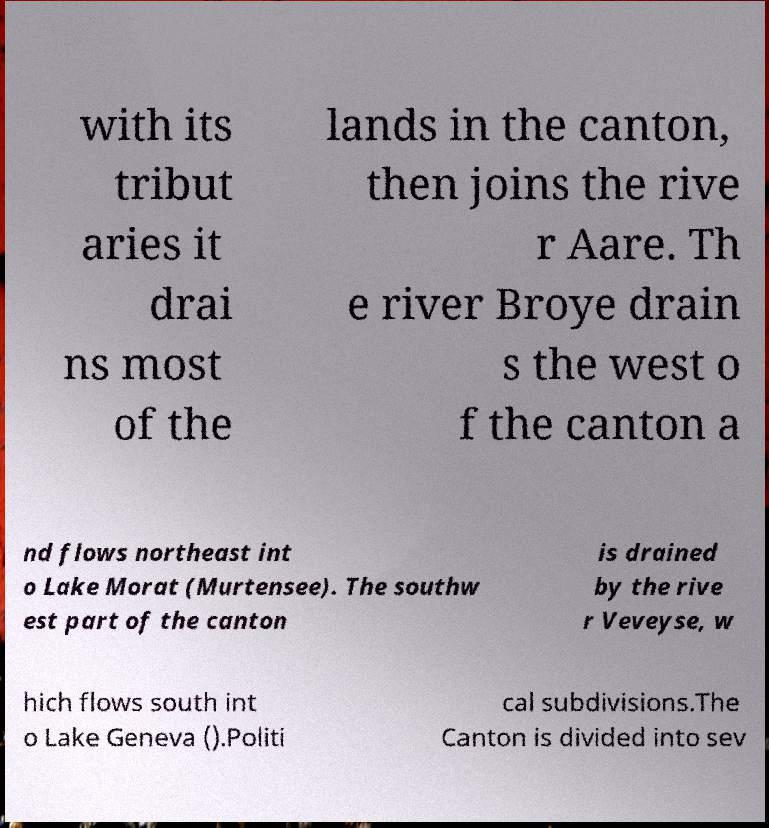Please read and relay the text visible in this image. What does it say? with its tribut aries it drai ns most of the lands in the canton, then joins the rive r Aare. Th e river Broye drain s the west o f the canton a nd flows northeast int o Lake Morat (Murtensee). The southw est part of the canton is drained by the rive r Veveyse, w hich flows south int o Lake Geneva ().Politi cal subdivisions.The Canton is divided into sev 